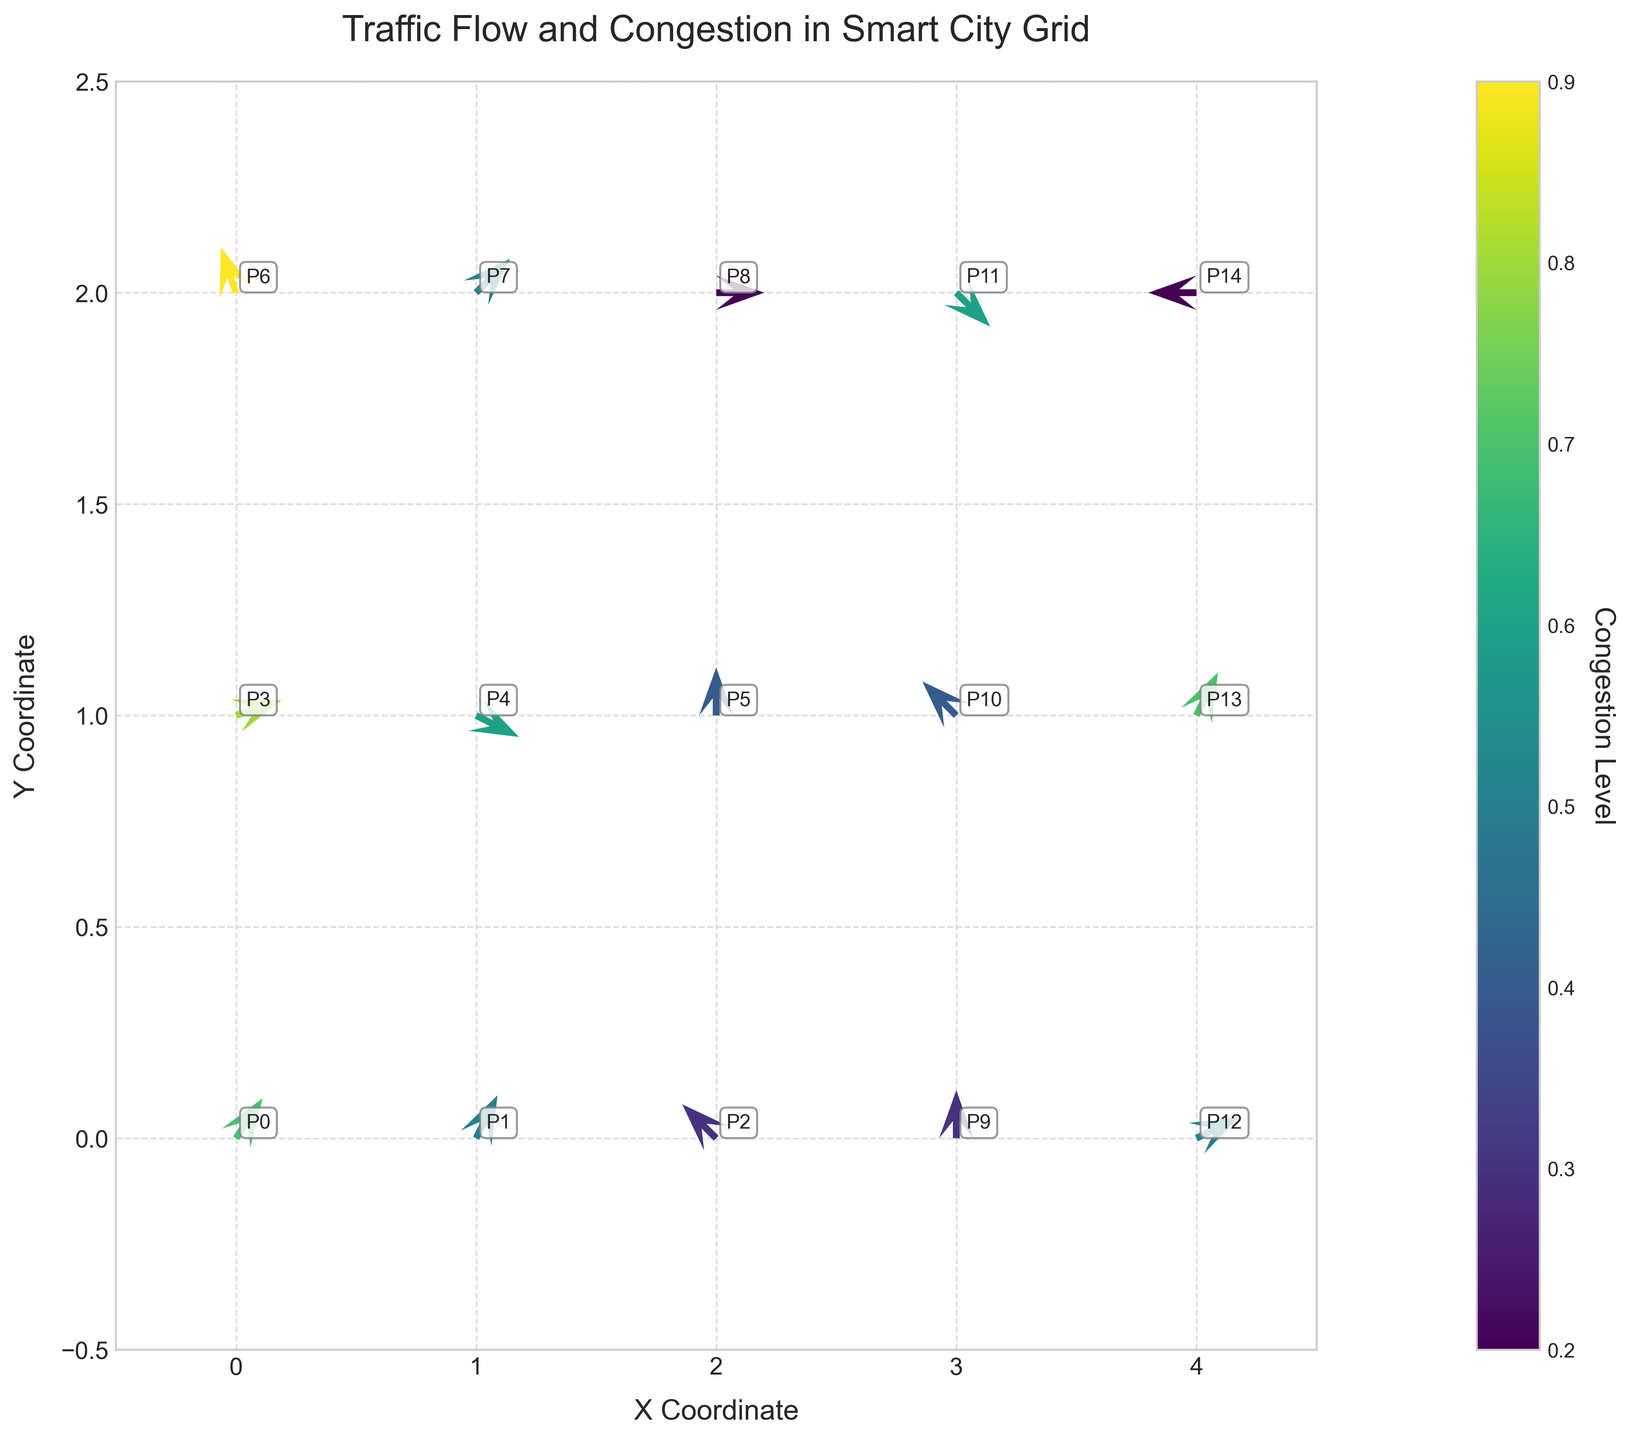What's the title of the figure? The title is located at the top of the figure and usually provides a summary of what the chart represents.
Answer: Traffic Flow and Congestion in Smart City Grid How many data points are plotted on the figure? Data points correspond to locations where arrows indicate traffic flow. By counting these points, we determine the number of data points.
Answer: 15 What are the axis labels for the plot? The axis labels are written beside the respective axes and indicate what each axis represents.
Answer: X Coordinate and Y Coordinate Which point has the highest congestion level? The congestion levels are represented by the color intensity of the arrows. The point with the darkest color corresponds to the highest congestion level. Identifying this point in the figure will provide the answer.
Answer: P6 What's the direction of the arrow at the coordinates (3, 0)? Arrows indicate the direction of traffic flow. By looking at the arrow starting at coordinates (3, 0), we can determine which direction it points.
Answer: Upward Compare the congestion levels at points (0, 2) and (2, 2). Which one is higher? By observing the color of the arrows at these points, we can compare their intensities. The point with the darker color has a higher congestion level.
Answer: (0, 2) has higher congestion What is the net vertical traffic flow (using `v` values) at x=1 across all y-coordinates? To find net vertical traffic flow, sum the vertical components `v` at x=1.
Answer: 2 (2 + -1 + 1 + 0 = 2) Which point has a lower congestion level: (4, 2) or (4, 1)? Compare the congestion levels by looking at the color of the arrows at these points. The lighter color indicates lower congestion.
Answer: (4, 2) Considering all arrows at x=2, what is the average congestion level? To get the average, sum the congestion levels at x=2 and then divide by the number of arrows at that x-coordinate.
Answer: 0.3 (average) How many arrows point to the left? By counting the arrows that point to the left direction across the entire plot, we determine the number.
Answer: 3 